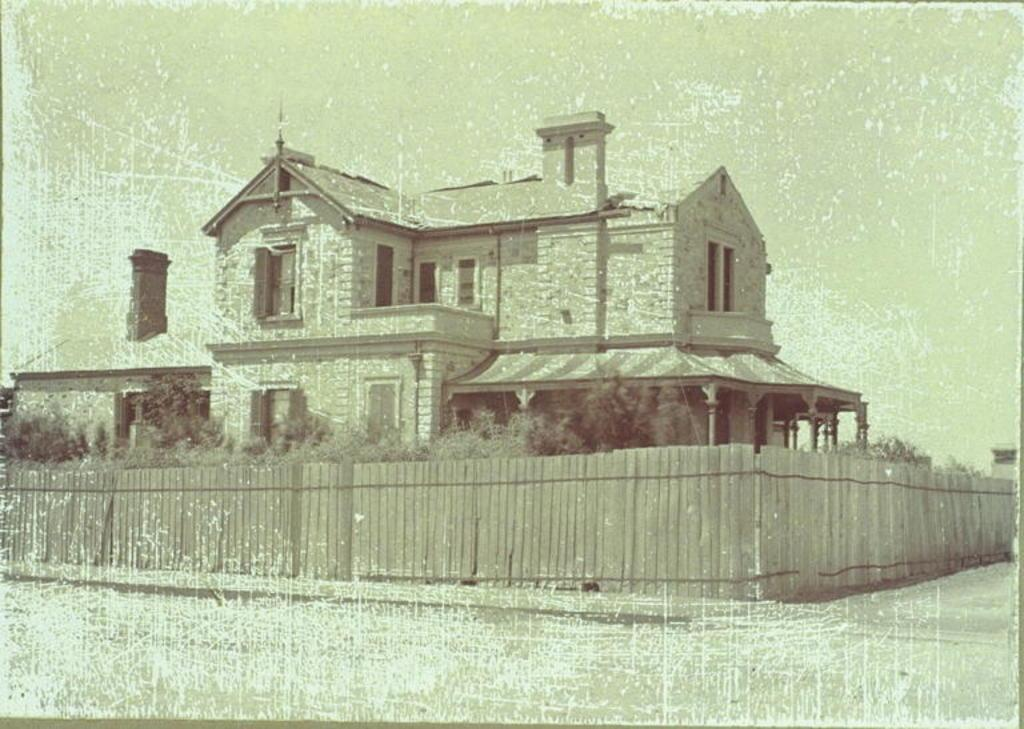What type of image is displayed in the picture? There is an old photograph of a building in the image. What surrounds the building in the image? There is a fence around the building in the image. What type of vegetation can be seen in the image? There are plants and trees in the image. What knowledge can be gained from the shade provided by the trees in the image? There is no shade provided by the trees in the image, as the trees are not directly over the building or any other objects. 